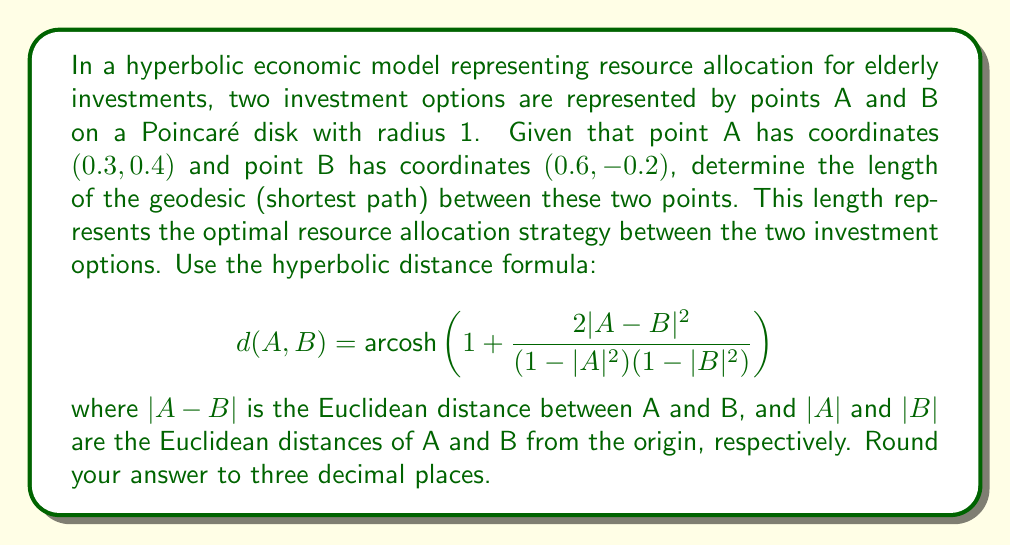Teach me how to tackle this problem. To solve this problem, we'll follow these steps:

1) Calculate $|A|$ and $|B|$:
   $|A| = \sqrt{0.3^2 + 0.4^2} = \sqrt{0.25} = 0.5$
   $|B| = \sqrt{0.6^2 + (-0.2)^2} = \sqrt{0.4} \approx 0.6325$

2) Calculate $|A-B|$:
   $|A-B| = \sqrt{(0.6-0.3)^2 + (-0.2-0.4)^2} = \sqrt{0.3^2 + (-0.6)^2} = \sqrt{0.45} \approx 0.6708$

3) Now, let's substitute these values into the hyperbolic distance formula:

   $$d(A,B) = \text{arcosh}\left(1 + \frac{2(0.6708)^2}{(1-0.5^2)(1-0.6325^2)}\right)$$

4) Simplify:
   $$d(A,B) = \text{arcosh}\left(1 + \frac{2(0.4500)}{(0.75)(0.6000)}\right)$$
   $$d(A,B) = \text{arcosh}\left(1 + \frac{0.9000}{0.4500}\right)$$
   $$d(A,B) = \text{arcosh}(3)$$

5) Calculate the final result:
   $$d(A,B) \approx 1.7627$$

6) Rounding to three decimal places:
   $$d(A,B) \approx 1.763$$

This value represents the optimal resource allocation strategy between the two investment options in the hyperbolic economic model.
Answer: 1.763 